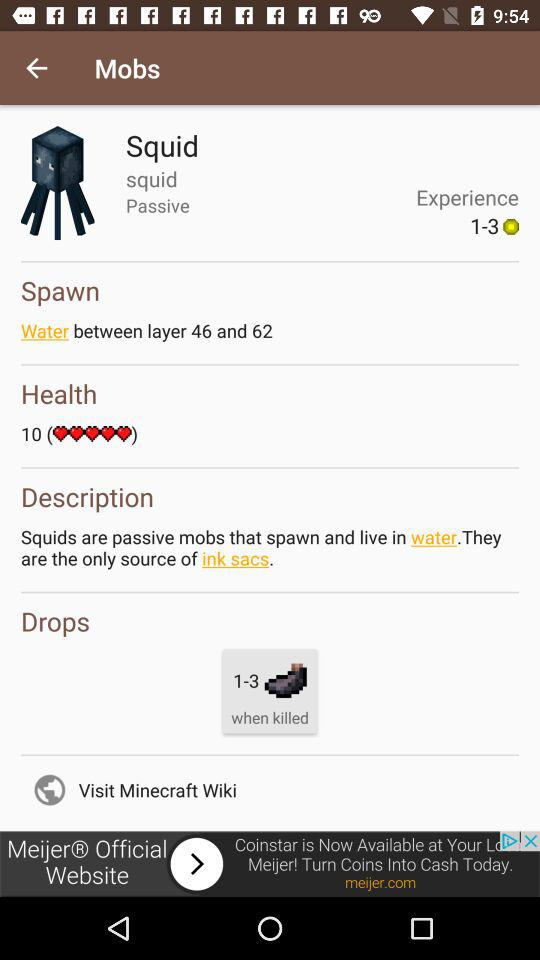What is the numbers in spawn?
When the provided information is insufficient, respond with <no answer>. <no answer> 